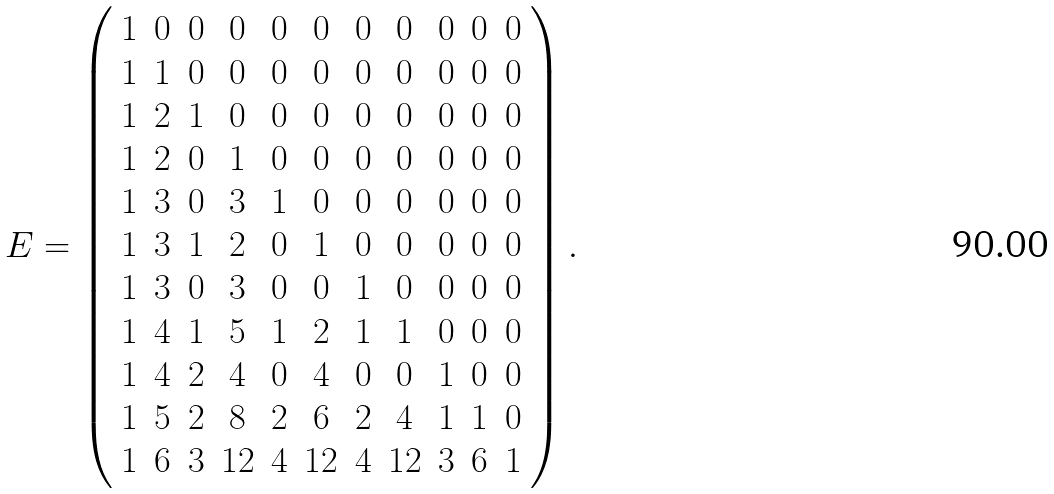Convert formula to latex. <formula><loc_0><loc_0><loc_500><loc_500>E = \left ( \begin{array} { c c c c c c c c c c c } 1 & 0 & 0 & 0 & 0 & 0 & 0 & 0 & 0 & 0 & 0 \\ 1 & 1 & 0 & 0 & 0 & 0 & 0 & 0 & 0 & 0 & 0 \\ 1 & 2 & 1 & 0 & 0 & 0 & 0 & 0 & 0 & 0 & 0 \\ 1 & 2 & 0 & 1 & 0 & 0 & 0 & 0 & 0 & 0 & 0 \\ 1 & 3 & 0 & 3 & 1 & 0 & 0 & 0 & 0 & 0 & 0 \\ 1 & 3 & 1 & 2 & 0 & 1 & 0 & 0 & 0 & 0 & 0 \\ 1 & 3 & 0 & 3 & 0 & 0 & 1 & 0 & 0 & 0 & 0 \\ 1 & 4 & 1 & 5 & 1 & 2 & 1 & 1 & 0 & 0 & 0 \\ 1 & 4 & 2 & 4 & 0 & 4 & 0 & 0 & 1 & 0 & 0 \\ 1 & 5 & 2 & 8 & 2 & 6 & 2 & 4 & 1 & 1 & 0 \\ 1 & 6 & 3 & 1 2 & 4 & 1 2 & 4 & 1 2 & 3 & 6 & 1 \\ \end{array} \right ) .</formula> 